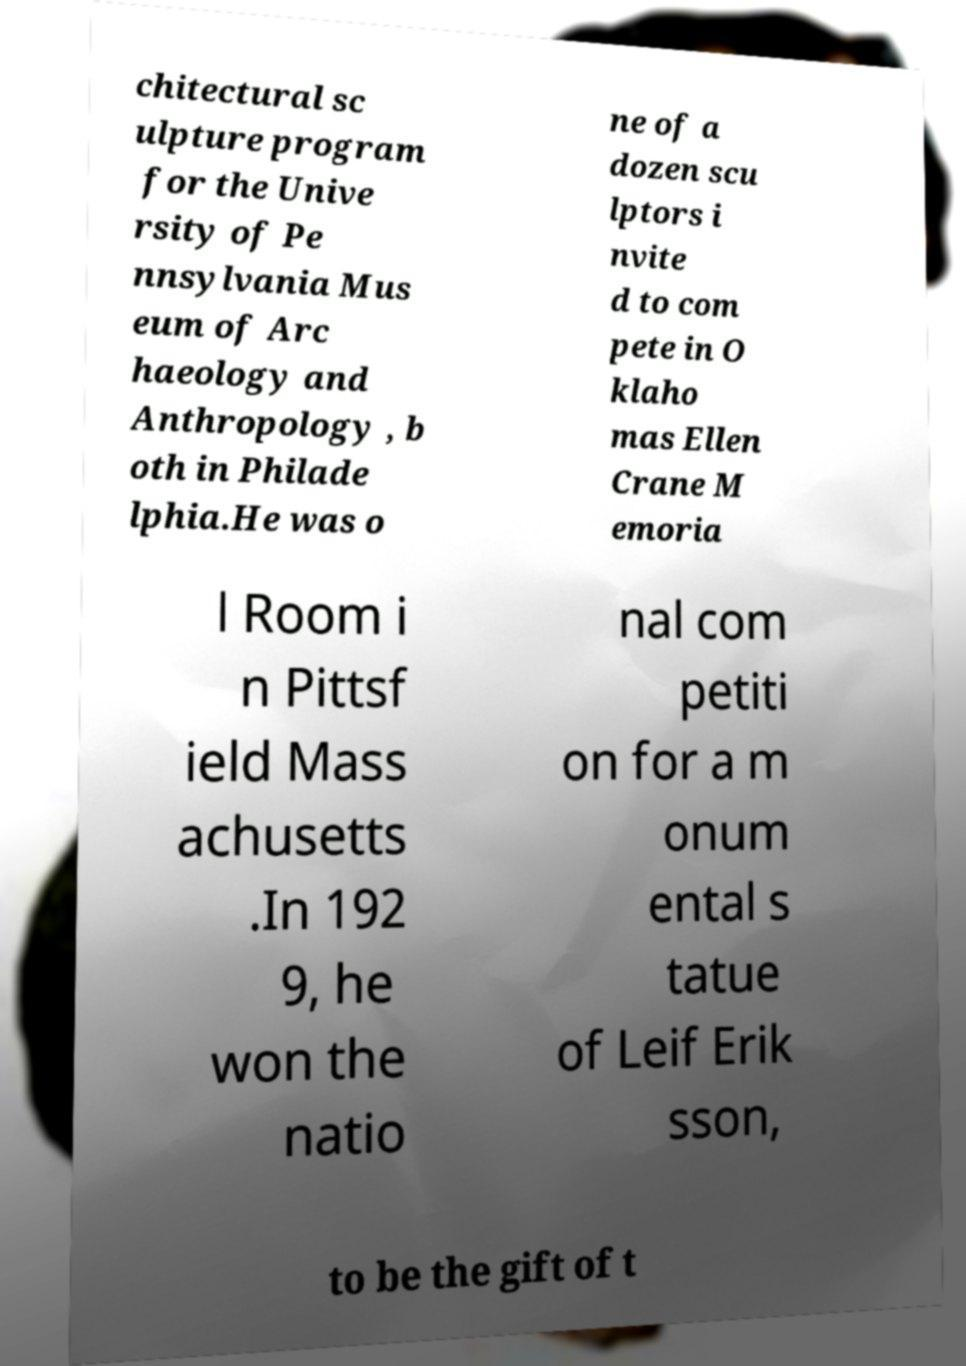Can you read and provide the text displayed in the image?This photo seems to have some interesting text. Can you extract and type it out for me? chitectural sc ulpture program for the Unive rsity of Pe nnsylvania Mus eum of Arc haeology and Anthropology , b oth in Philade lphia.He was o ne of a dozen scu lptors i nvite d to com pete in O klaho mas Ellen Crane M emoria l Room i n Pittsf ield Mass achusetts .In 192 9, he won the natio nal com petiti on for a m onum ental s tatue of Leif Erik sson, to be the gift of t 